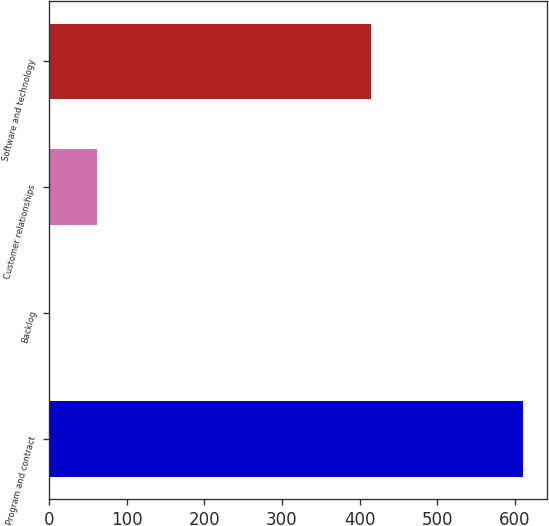Convert chart to OTSL. <chart><loc_0><loc_0><loc_500><loc_500><bar_chart><fcel>Program and contract<fcel>Backlog<fcel>Customer relationships<fcel>Software and technology<nl><fcel>611<fcel>1<fcel>62<fcel>415<nl></chart> 